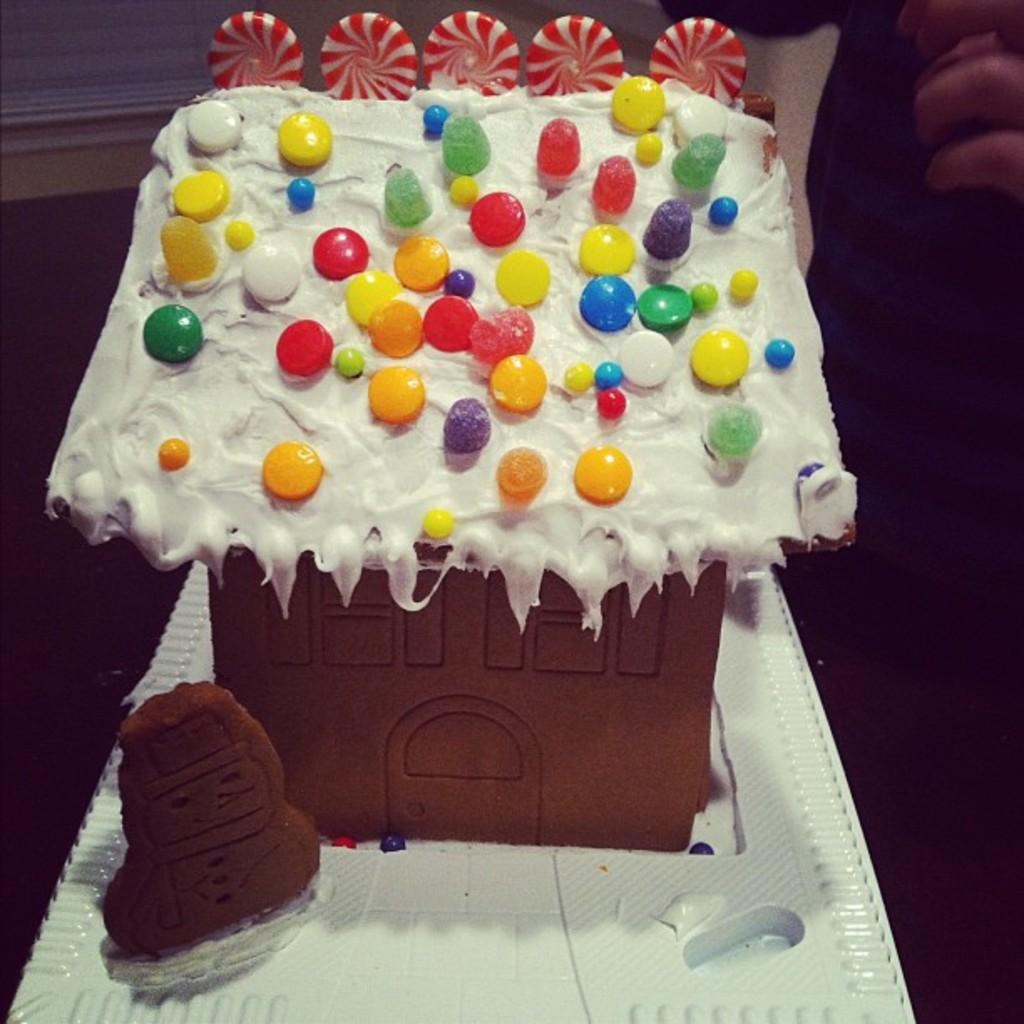What is the main subject of the image? There is a cake in the image. What can be seen on the cake? The cake has cream on it, and there are candies on the cake. On what surface is the cake placed? The cake is placed on a white surface. What type of fiction is the cake reading in the image? There is no indication in the image that the cake is reading any fiction, as cakes do not have the ability to read. 